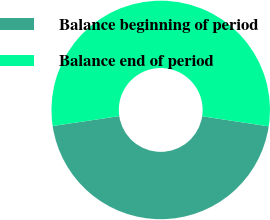<chart> <loc_0><loc_0><loc_500><loc_500><pie_chart><fcel>Balance beginning of period<fcel>Balance end of period<nl><fcel>45.24%<fcel>54.76%<nl></chart> 